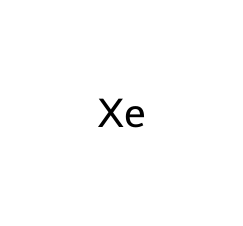What is the atomic number of xenon? The atomic number is indicated by the number of protons in the nucleus of the xenon atom, which is crucial for identifying the element. For xenon, this value is 54.
Answer: 54 How many atoms are present in xenon? The chemical representation [Xe] shows there is one atom present, as it symbolizes the element xenon itself without any additional atoms or molecules.
Answer: 1 Is xenon a gas at room temperature? Xenon is classified as a noble gas, and noble gases are typically gaseous at room temperature due to their molecular structure, which includes a complete outer electron shell.
Answer: yes What type of chemical bonding is present in xenon? Noble gases like xenon are monoatomic and do not form bonds with other atoms under normal conditions; thus, they are present as single atoms in their gaseous form.
Answer: none What is the use of xenon in high-intensity lamps? Xenon is often used in high-intensity discharge lamps due to its ability to emit a bright light when ionized, making it effective for illumination in various settings, including legislative chambers.
Answer: illumination How does the noble gas property of xenon influence its reactivity? Noble gases have a complete valence shell, which makes them very stable and mostly non-reactive, thus contributing to xenon's limited chemical reactivity and its use in lighting without forming compounds.
Answer: low reactivity What color of light does xenon emit when excited? When xenon gas is ionized, it emits a bright blue or white light, which is characteristic of the light produced in certain high-intensity lamps that utilize xenon.
Answer: blue/white 